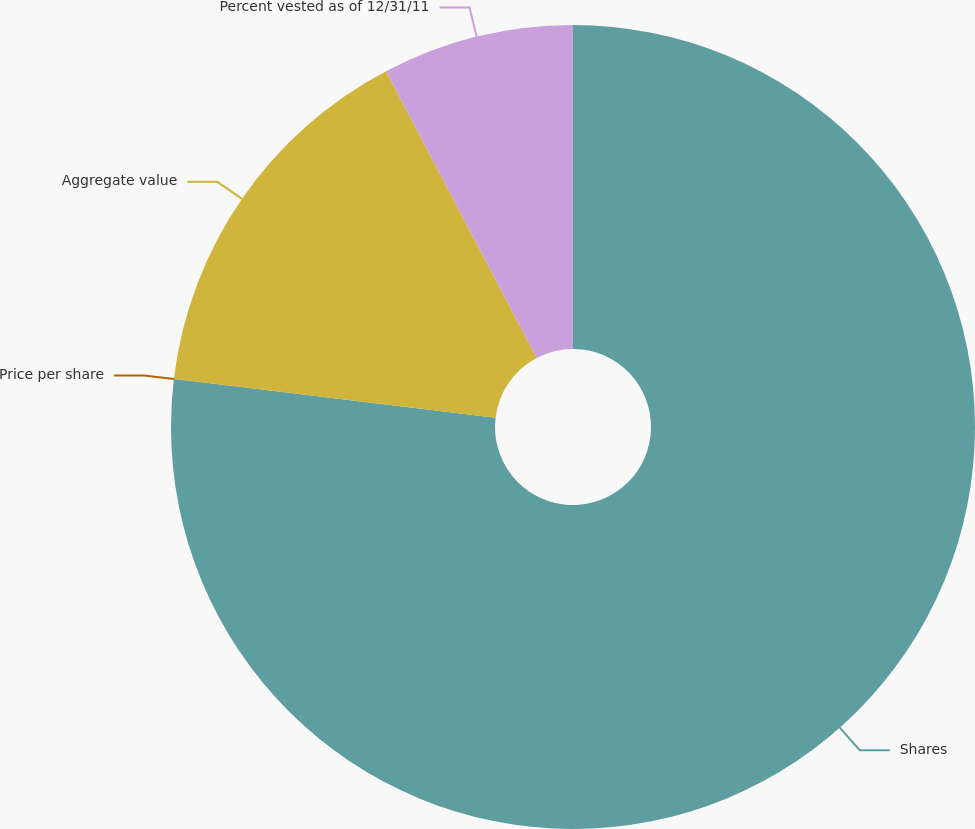Convert chart. <chart><loc_0><loc_0><loc_500><loc_500><pie_chart><fcel>Shares<fcel>Price per share<fcel>Aggregate value<fcel>Percent vested as of 12/31/11<nl><fcel>76.9%<fcel>0.01%<fcel>15.39%<fcel>7.7%<nl></chart> 